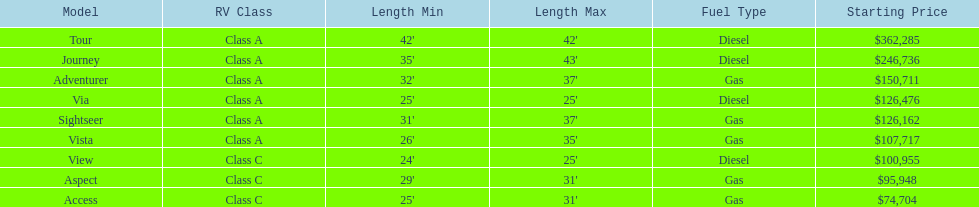Which model is a diesel, the tour or the aspect? Tour. Write the full table. {'header': ['Model', 'RV Class', 'Length Min', 'Length Max', 'Fuel Type', 'Starting Price'], 'rows': [['Tour', 'Class A', "42'", "42'", 'Diesel', '$362,285'], ['Journey', 'Class A', "35'", "43'", 'Diesel', '$246,736'], ['Adventurer', 'Class A', "32'", "37'", 'Gas', '$150,711'], ['Via', 'Class A', "25'", "25'", 'Diesel', '$126,476'], ['Sightseer', 'Class A', "31'", "37'", 'Gas', '$126,162'], ['Vista', 'Class A', "26'", "35'", 'Gas', '$107,717'], ['View', 'Class C', "24'", "25'", 'Diesel', '$100,955'], ['Aspect', 'Class C', "29'", "31'", 'Gas', '$95,948'], ['Access', 'Class C', "25'", "31'", 'Gas', '$74,704']]} 